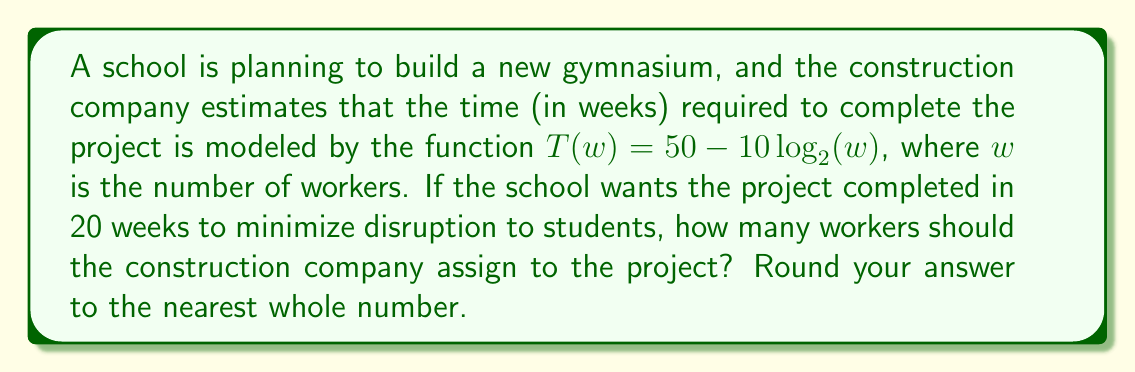Solve this math problem. Let's approach this step-by-step:

1) We're given the function $T(w) = 50 - 10\log_2(w)$, where:
   $T$ is the time in weeks
   $w$ is the number of workers

2) We want to find $w$ when $T = 20$ weeks. So, we can set up the equation:
   $20 = 50 - 10\log_2(w)$

3) Let's solve for $\log_2(w)$:
   $20 - 50 = -10\log_2(w)$
   $-30 = -10\log_2(w)$
   $3 = \log_2(w)$

4) Now, we need to solve for $w$. We can do this by applying $2^x$ to both sides:
   $2^3 = 2^{\log_2(w)}$
   $8 = w$

5) Therefore, the construction company should assign 8 workers to complete the project in 20 weeks.
Answer: 8 workers 